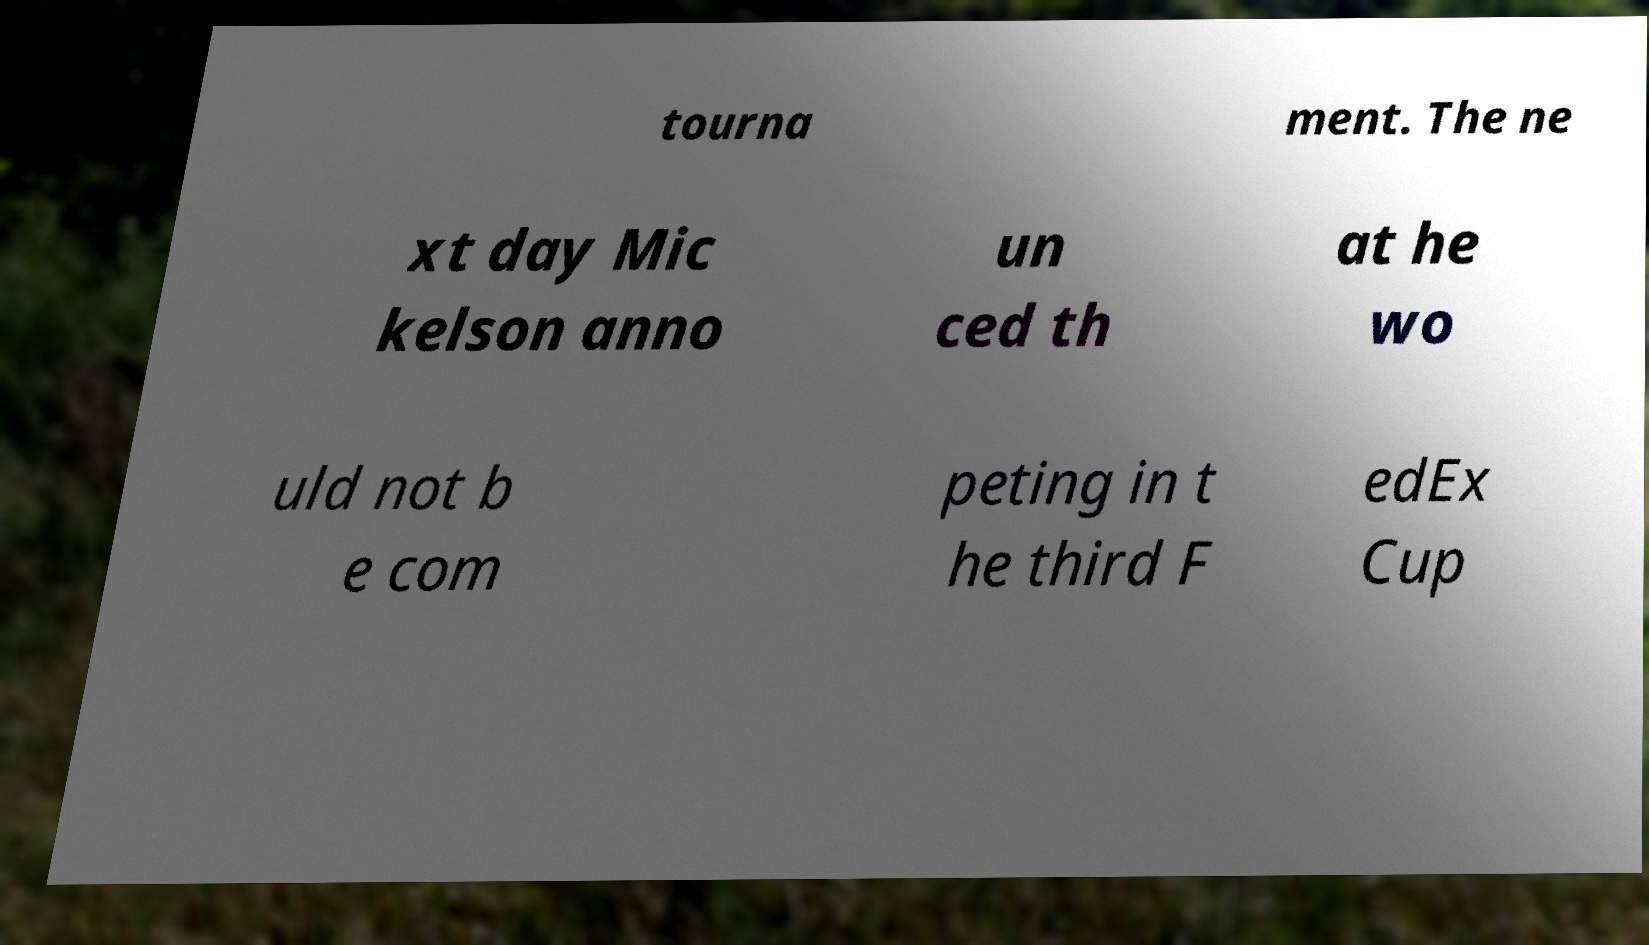Please read and relay the text visible in this image. What does it say? tourna ment. The ne xt day Mic kelson anno un ced th at he wo uld not b e com peting in t he third F edEx Cup 